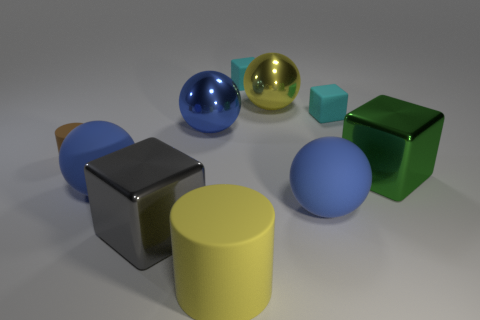Subtract all gray cylinders. How many blue balls are left? 3 Subtract 1 spheres. How many spheres are left? 3 Subtract all gray spheres. Subtract all blue blocks. How many spheres are left? 4 Subtract all cubes. How many objects are left? 6 Subtract 0 red spheres. How many objects are left? 10 Subtract all big yellow matte cylinders. Subtract all large green objects. How many objects are left? 8 Add 9 large blue metallic objects. How many large blue metallic objects are left? 10 Add 3 gray metal objects. How many gray metal objects exist? 4 